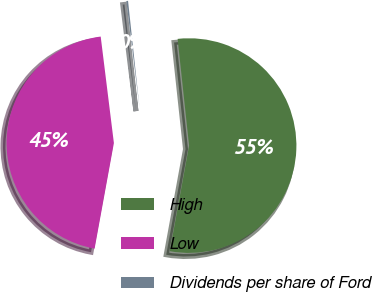<chart> <loc_0><loc_0><loc_500><loc_500><pie_chart><fcel>High<fcel>Low<fcel>Dividends per share of Ford<nl><fcel>54.58%<fcel>45.16%<fcel>0.26%<nl></chart> 